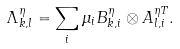Convert formula to latex. <formula><loc_0><loc_0><loc_500><loc_500>\Lambda _ { k , l } ^ { \eta } = \sum _ { i } \mu _ { i } B ^ { \eta } _ { k , i } \otimes A ^ { \eta T } _ { l , i } .</formula> 